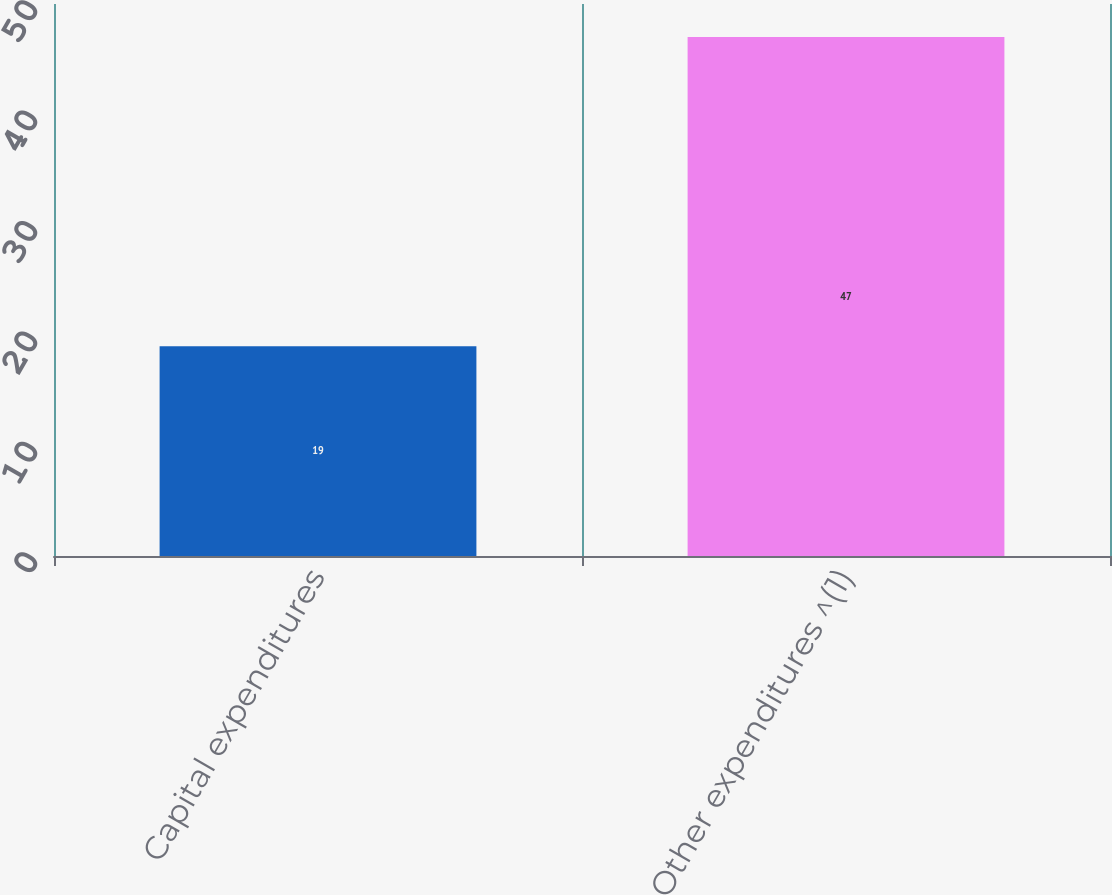Convert chart to OTSL. <chart><loc_0><loc_0><loc_500><loc_500><bar_chart><fcel>Capital expenditures<fcel>Other expenditures ^(1)<nl><fcel>19<fcel>47<nl></chart> 